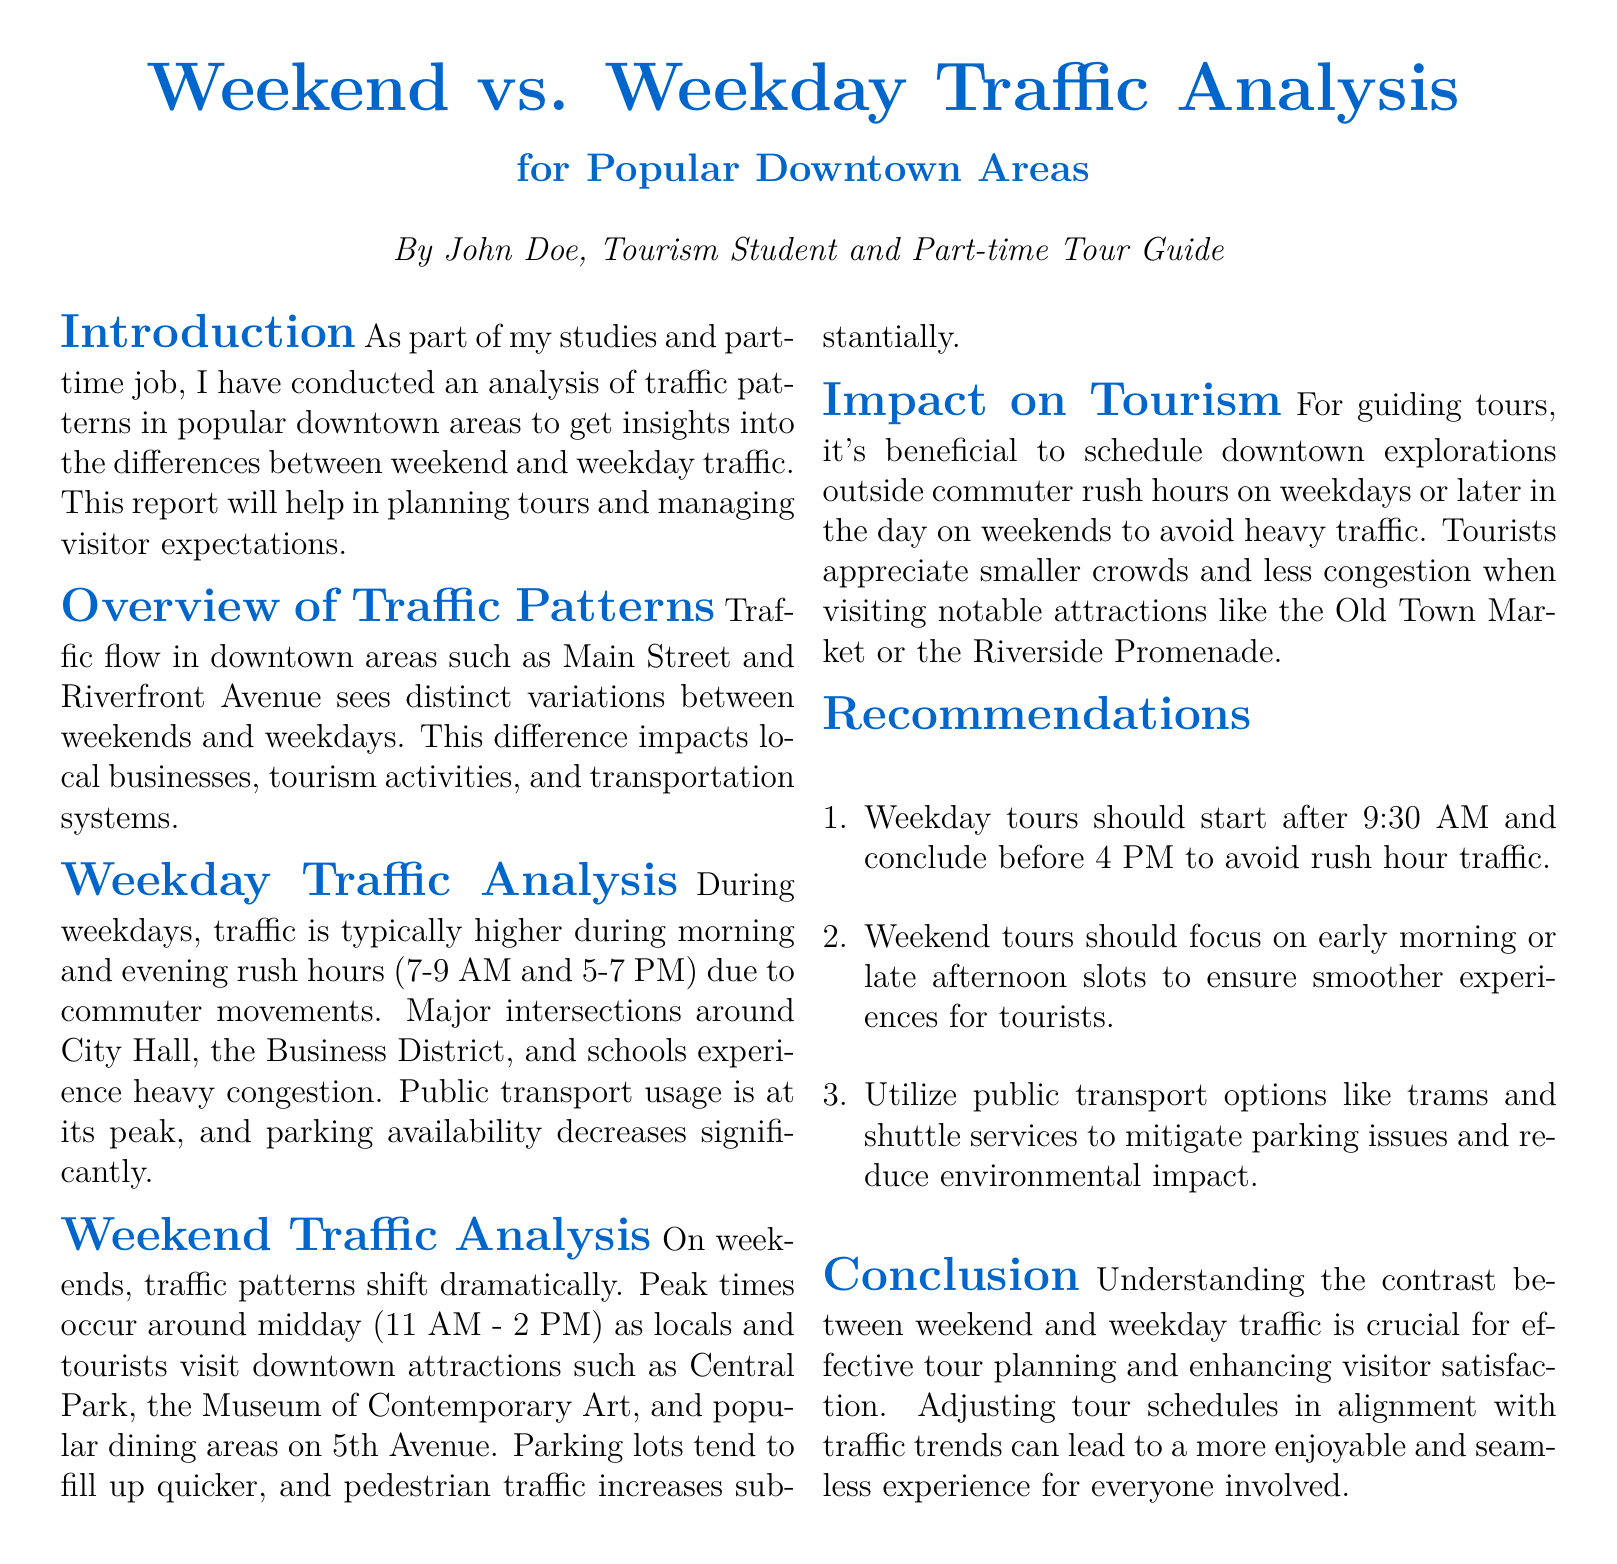What are the peak weekday traffic hours? The document specifies that peak traffic hours during weekdays occur from 7-9 AM and 5-7 PM.
Answer: 7-9 AM and 5-7 PM What locations are mentioned as experiencing heavy congestion on weekdays? The document lists City Hall, the Business District, and schools as major intersections with heavy congestion during weekdays.
Answer: City Hall, the Business District, and schools When does peak traffic occur on weekends? The report indicates that peak traffic on weekends occurs around midday, specifically from 11 AM to 2 PM.
Answer: 11 AM - 2 PM What is a recommended start time for weekday tours? The document recommends that weekday tours should start after 9:30 AM to avoid rush hour traffic.
Answer: After 9:30 AM How does weekend pedestrian traffic compare to weekdays? The analysis in the document mentions that pedestrian traffic increases substantially on weekends.
Answer: Increases substantially Where should tours be scheduled on weekends for better experiences? The document suggests scheduling weekend tours for early morning or late afternoon slots.
Answer: Early morning or late afternoon Who authored the traffic analysis report? The report was authored by John Doe, who is identified as a tourism student and part-time tour guide.
Answer: John Doe What is the impact of traffic patterns on local businesses? The document explains that variations in traffic patterns impact local businesses as well as tourism activities.
Answer: Impact local businesses What are public transport options suggested in the recommendations? The document suggests utilizing trams and shuttle services as public transport options.
Answer: Trams and shuttle services 